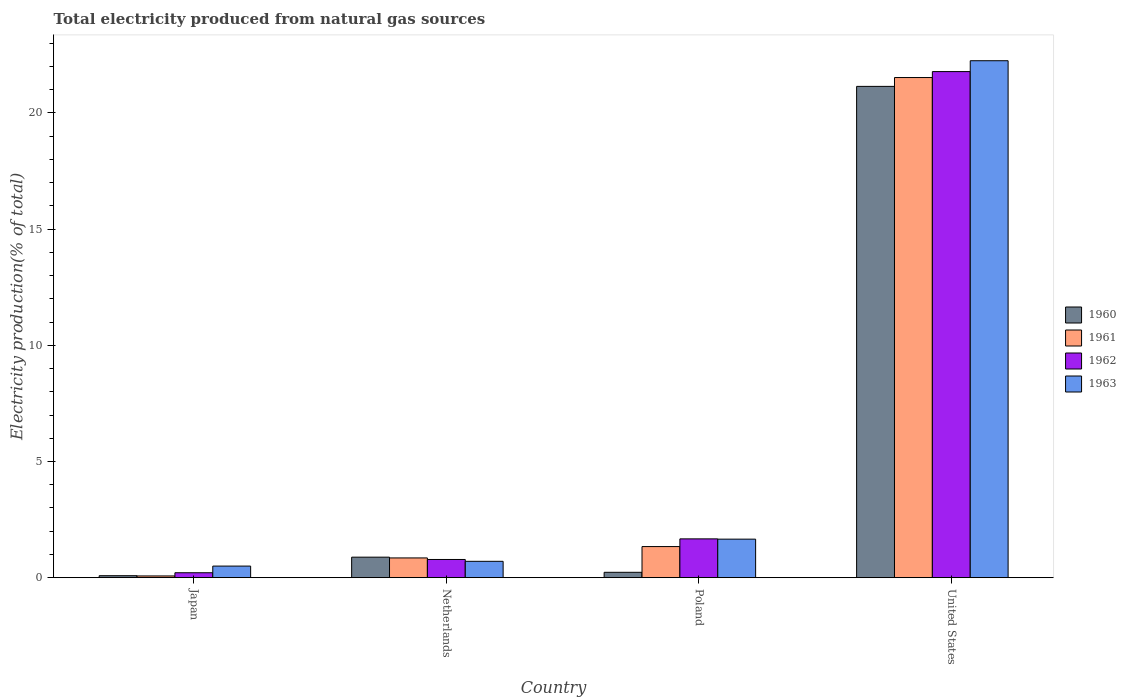How many different coloured bars are there?
Provide a short and direct response. 4. Are the number of bars per tick equal to the number of legend labels?
Offer a terse response. Yes. Are the number of bars on each tick of the X-axis equal?
Make the answer very short. Yes. How many bars are there on the 4th tick from the right?
Your answer should be compact. 4. In how many cases, is the number of bars for a given country not equal to the number of legend labels?
Your answer should be very brief. 0. What is the total electricity produced in 1963 in United States?
Ensure brevity in your answer.  22.24. Across all countries, what is the maximum total electricity produced in 1961?
Your answer should be very brief. 21.52. Across all countries, what is the minimum total electricity produced in 1962?
Your answer should be compact. 0.21. In which country was the total electricity produced in 1962 minimum?
Make the answer very short. Japan. What is the total total electricity produced in 1960 in the graph?
Offer a very short reply. 22.34. What is the difference between the total electricity produced in 1961 in Netherlands and that in United States?
Your answer should be compact. -20.67. What is the difference between the total electricity produced in 1963 in United States and the total electricity produced in 1960 in Netherlands?
Make the answer very short. 21.36. What is the average total electricity produced in 1961 per country?
Your answer should be compact. 5.95. What is the difference between the total electricity produced of/in 1962 and total electricity produced of/in 1961 in Netherlands?
Give a very brief answer. -0.07. What is the ratio of the total electricity produced in 1961 in Poland to that in United States?
Offer a very short reply. 0.06. Is the total electricity produced in 1962 in Japan less than that in Poland?
Offer a terse response. Yes. Is the difference between the total electricity produced in 1962 in Japan and United States greater than the difference between the total electricity produced in 1961 in Japan and United States?
Provide a succinct answer. No. What is the difference between the highest and the second highest total electricity produced in 1961?
Ensure brevity in your answer.  -0.49. What is the difference between the highest and the lowest total electricity produced in 1962?
Your response must be concise. 21.56. Is the sum of the total electricity produced in 1961 in Japan and Netherlands greater than the maximum total electricity produced in 1962 across all countries?
Your answer should be compact. No. Is it the case that in every country, the sum of the total electricity produced in 1960 and total electricity produced in 1961 is greater than the sum of total electricity produced in 1962 and total electricity produced in 1963?
Keep it short and to the point. No. Is it the case that in every country, the sum of the total electricity produced in 1963 and total electricity produced in 1960 is greater than the total electricity produced in 1961?
Ensure brevity in your answer.  Yes. How many countries are there in the graph?
Offer a very short reply. 4. Are the values on the major ticks of Y-axis written in scientific E-notation?
Your answer should be compact. No. Does the graph contain grids?
Ensure brevity in your answer.  No. What is the title of the graph?
Provide a succinct answer. Total electricity produced from natural gas sources. What is the label or title of the X-axis?
Offer a terse response. Country. What is the label or title of the Y-axis?
Give a very brief answer. Electricity production(% of total). What is the Electricity production(% of total) of 1960 in Japan?
Give a very brief answer. 0.09. What is the Electricity production(% of total) in 1961 in Japan?
Your answer should be very brief. 0.08. What is the Electricity production(% of total) of 1962 in Japan?
Your answer should be very brief. 0.21. What is the Electricity production(% of total) in 1963 in Japan?
Offer a terse response. 0.5. What is the Electricity production(% of total) of 1960 in Netherlands?
Give a very brief answer. 0.88. What is the Electricity production(% of total) in 1961 in Netherlands?
Your answer should be very brief. 0.85. What is the Electricity production(% of total) in 1962 in Netherlands?
Provide a short and direct response. 0.78. What is the Electricity production(% of total) of 1963 in Netherlands?
Make the answer very short. 0.71. What is the Electricity production(% of total) of 1960 in Poland?
Ensure brevity in your answer.  0.23. What is the Electricity production(% of total) in 1961 in Poland?
Your answer should be very brief. 1.34. What is the Electricity production(% of total) of 1962 in Poland?
Offer a terse response. 1.67. What is the Electricity production(% of total) in 1963 in Poland?
Your answer should be compact. 1.66. What is the Electricity production(% of total) of 1960 in United States?
Keep it short and to the point. 21.14. What is the Electricity production(% of total) of 1961 in United States?
Offer a terse response. 21.52. What is the Electricity production(% of total) of 1962 in United States?
Give a very brief answer. 21.78. What is the Electricity production(% of total) in 1963 in United States?
Provide a succinct answer. 22.24. Across all countries, what is the maximum Electricity production(% of total) of 1960?
Provide a short and direct response. 21.14. Across all countries, what is the maximum Electricity production(% of total) in 1961?
Keep it short and to the point. 21.52. Across all countries, what is the maximum Electricity production(% of total) of 1962?
Provide a succinct answer. 21.78. Across all countries, what is the maximum Electricity production(% of total) of 1963?
Your answer should be very brief. 22.24. Across all countries, what is the minimum Electricity production(% of total) in 1960?
Keep it short and to the point. 0.09. Across all countries, what is the minimum Electricity production(% of total) in 1961?
Your answer should be very brief. 0.08. Across all countries, what is the minimum Electricity production(% of total) of 1962?
Offer a very short reply. 0.21. Across all countries, what is the minimum Electricity production(% of total) in 1963?
Keep it short and to the point. 0.5. What is the total Electricity production(% of total) in 1960 in the graph?
Give a very brief answer. 22.34. What is the total Electricity production(% of total) of 1961 in the graph?
Your answer should be compact. 23.79. What is the total Electricity production(% of total) of 1962 in the graph?
Provide a succinct answer. 24.45. What is the total Electricity production(% of total) in 1963 in the graph?
Your answer should be compact. 25.11. What is the difference between the Electricity production(% of total) of 1960 in Japan and that in Netherlands?
Your answer should be very brief. -0.8. What is the difference between the Electricity production(% of total) of 1961 in Japan and that in Netherlands?
Offer a terse response. -0.78. What is the difference between the Electricity production(% of total) of 1962 in Japan and that in Netherlands?
Your answer should be compact. -0.57. What is the difference between the Electricity production(% of total) of 1963 in Japan and that in Netherlands?
Keep it short and to the point. -0.21. What is the difference between the Electricity production(% of total) of 1960 in Japan and that in Poland?
Give a very brief answer. -0.15. What is the difference between the Electricity production(% of total) in 1961 in Japan and that in Poland?
Offer a terse response. -1.26. What is the difference between the Electricity production(% of total) of 1962 in Japan and that in Poland?
Keep it short and to the point. -1.46. What is the difference between the Electricity production(% of total) in 1963 in Japan and that in Poland?
Provide a short and direct response. -1.16. What is the difference between the Electricity production(% of total) of 1960 in Japan and that in United States?
Your answer should be compact. -21.05. What is the difference between the Electricity production(% of total) of 1961 in Japan and that in United States?
Offer a very short reply. -21.45. What is the difference between the Electricity production(% of total) in 1962 in Japan and that in United States?
Keep it short and to the point. -21.56. What is the difference between the Electricity production(% of total) in 1963 in Japan and that in United States?
Provide a short and direct response. -21.74. What is the difference between the Electricity production(% of total) in 1960 in Netherlands and that in Poland?
Offer a very short reply. 0.65. What is the difference between the Electricity production(% of total) in 1961 in Netherlands and that in Poland?
Your answer should be compact. -0.49. What is the difference between the Electricity production(% of total) in 1962 in Netherlands and that in Poland?
Ensure brevity in your answer.  -0.89. What is the difference between the Electricity production(% of total) of 1963 in Netherlands and that in Poland?
Keep it short and to the point. -0.95. What is the difference between the Electricity production(% of total) in 1960 in Netherlands and that in United States?
Your answer should be compact. -20.26. What is the difference between the Electricity production(% of total) in 1961 in Netherlands and that in United States?
Provide a short and direct response. -20.67. What is the difference between the Electricity production(% of total) of 1962 in Netherlands and that in United States?
Your answer should be compact. -20.99. What is the difference between the Electricity production(% of total) of 1963 in Netherlands and that in United States?
Your answer should be compact. -21.54. What is the difference between the Electricity production(% of total) of 1960 in Poland and that in United States?
Offer a very short reply. -20.91. What is the difference between the Electricity production(% of total) of 1961 in Poland and that in United States?
Your answer should be very brief. -20.18. What is the difference between the Electricity production(% of total) in 1962 in Poland and that in United States?
Ensure brevity in your answer.  -20.11. What is the difference between the Electricity production(% of total) of 1963 in Poland and that in United States?
Give a very brief answer. -20.59. What is the difference between the Electricity production(% of total) in 1960 in Japan and the Electricity production(% of total) in 1961 in Netherlands?
Offer a terse response. -0.76. What is the difference between the Electricity production(% of total) of 1960 in Japan and the Electricity production(% of total) of 1962 in Netherlands?
Your response must be concise. -0.7. What is the difference between the Electricity production(% of total) of 1960 in Japan and the Electricity production(% of total) of 1963 in Netherlands?
Ensure brevity in your answer.  -0.62. What is the difference between the Electricity production(% of total) of 1961 in Japan and the Electricity production(% of total) of 1962 in Netherlands?
Provide a succinct answer. -0.71. What is the difference between the Electricity production(% of total) in 1961 in Japan and the Electricity production(% of total) in 1963 in Netherlands?
Your answer should be compact. -0.63. What is the difference between the Electricity production(% of total) in 1962 in Japan and the Electricity production(% of total) in 1963 in Netherlands?
Ensure brevity in your answer.  -0.49. What is the difference between the Electricity production(% of total) in 1960 in Japan and the Electricity production(% of total) in 1961 in Poland?
Provide a short and direct response. -1.25. What is the difference between the Electricity production(% of total) in 1960 in Japan and the Electricity production(% of total) in 1962 in Poland?
Offer a very short reply. -1.58. What is the difference between the Electricity production(% of total) of 1960 in Japan and the Electricity production(% of total) of 1963 in Poland?
Give a very brief answer. -1.57. What is the difference between the Electricity production(% of total) of 1961 in Japan and the Electricity production(% of total) of 1962 in Poland?
Keep it short and to the point. -1.6. What is the difference between the Electricity production(% of total) in 1961 in Japan and the Electricity production(% of total) in 1963 in Poland?
Keep it short and to the point. -1.58. What is the difference between the Electricity production(% of total) in 1962 in Japan and the Electricity production(% of total) in 1963 in Poland?
Offer a terse response. -1.45. What is the difference between the Electricity production(% of total) of 1960 in Japan and the Electricity production(% of total) of 1961 in United States?
Provide a succinct answer. -21.43. What is the difference between the Electricity production(% of total) of 1960 in Japan and the Electricity production(% of total) of 1962 in United States?
Give a very brief answer. -21.69. What is the difference between the Electricity production(% of total) of 1960 in Japan and the Electricity production(% of total) of 1963 in United States?
Make the answer very short. -22.16. What is the difference between the Electricity production(% of total) of 1961 in Japan and the Electricity production(% of total) of 1962 in United States?
Your answer should be compact. -21.7. What is the difference between the Electricity production(% of total) of 1961 in Japan and the Electricity production(% of total) of 1963 in United States?
Offer a terse response. -22.17. What is the difference between the Electricity production(% of total) of 1962 in Japan and the Electricity production(% of total) of 1963 in United States?
Your answer should be compact. -22.03. What is the difference between the Electricity production(% of total) of 1960 in Netherlands and the Electricity production(% of total) of 1961 in Poland?
Offer a terse response. -0.46. What is the difference between the Electricity production(% of total) of 1960 in Netherlands and the Electricity production(% of total) of 1962 in Poland?
Your response must be concise. -0.79. What is the difference between the Electricity production(% of total) in 1960 in Netherlands and the Electricity production(% of total) in 1963 in Poland?
Ensure brevity in your answer.  -0.78. What is the difference between the Electricity production(% of total) in 1961 in Netherlands and the Electricity production(% of total) in 1962 in Poland?
Make the answer very short. -0.82. What is the difference between the Electricity production(% of total) of 1961 in Netherlands and the Electricity production(% of total) of 1963 in Poland?
Your answer should be very brief. -0.81. What is the difference between the Electricity production(% of total) of 1962 in Netherlands and the Electricity production(% of total) of 1963 in Poland?
Provide a succinct answer. -0.88. What is the difference between the Electricity production(% of total) of 1960 in Netherlands and the Electricity production(% of total) of 1961 in United States?
Offer a terse response. -20.64. What is the difference between the Electricity production(% of total) in 1960 in Netherlands and the Electricity production(% of total) in 1962 in United States?
Provide a succinct answer. -20.89. What is the difference between the Electricity production(% of total) in 1960 in Netherlands and the Electricity production(% of total) in 1963 in United States?
Your answer should be compact. -21.36. What is the difference between the Electricity production(% of total) in 1961 in Netherlands and the Electricity production(% of total) in 1962 in United States?
Provide a short and direct response. -20.93. What is the difference between the Electricity production(% of total) in 1961 in Netherlands and the Electricity production(% of total) in 1963 in United States?
Offer a very short reply. -21.39. What is the difference between the Electricity production(% of total) in 1962 in Netherlands and the Electricity production(% of total) in 1963 in United States?
Your answer should be compact. -21.46. What is the difference between the Electricity production(% of total) in 1960 in Poland and the Electricity production(% of total) in 1961 in United States?
Provide a short and direct response. -21.29. What is the difference between the Electricity production(% of total) in 1960 in Poland and the Electricity production(% of total) in 1962 in United States?
Keep it short and to the point. -21.55. What is the difference between the Electricity production(% of total) of 1960 in Poland and the Electricity production(% of total) of 1963 in United States?
Keep it short and to the point. -22.01. What is the difference between the Electricity production(% of total) of 1961 in Poland and the Electricity production(% of total) of 1962 in United States?
Your response must be concise. -20.44. What is the difference between the Electricity production(% of total) of 1961 in Poland and the Electricity production(% of total) of 1963 in United States?
Your answer should be compact. -20.91. What is the difference between the Electricity production(% of total) of 1962 in Poland and the Electricity production(% of total) of 1963 in United States?
Offer a terse response. -20.57. What is the average Electricity production(% of total) in 1960 per country?
Your answer should be very brief. 5.59. What is the average Electricity production(% of total) of 1961 per country?
Provide a succinct answer. 5.95. What is the average Electricity production(% of total) of 1962 per country?
Your answer should be compact. 6.11. What is the average Electricity production(% of total) of 1963 per country?
Provide a short and direct response. 6.28. What is the difference between the Electricity production(% of total) in 1960 and Electricity production(% of total) in 1961 in Japan?
Provide a succinct answer. 0.01. What is the difference between the Electricity production(% of total) of 1960 and Electricity production(% of total) of 1962 in Japan?
Provide a short and direct response. -0.13. What is the difference between the Electricity production(% of total) of 1960 and Electricity production(% of total) of 1963 in Japan?
Your answer should be compact. -0.41. What is the difference between the Electricity production(% of total) of 1961 and Electricity production(% of total) of 1962 in Japan?
Provide a short and direct response. -0.14. What is the difference between the Electricity production(% of total) of 1961 and Electricity production(% of total) of 1963 in Japan?
Offer a terse response. -0.42. What is the difference between the Electricity production(% of total) of 1962 and Electricity production(% of total) of 1963 in Japan?
Your response must be concise. -0.29. What is the difference between the Electricity production(% of total) of 1960 and Electricity production(% of total) of 1961 in Netherlands?
Your answer should be compact. 0.03. What is the difference between the Electricity production(% of total) in 1960 and Electricity production(% of total) in 1962 in Netherlands?
Ensure brevity in your answer.  0.1. What is the difference between the Electricity production(% of total) in 1960 and Electricity production(% of total) in 1963 in Netherlands?
Give a very brief answer. 0.18. What is the difference between the Electricity production(% of total) in 1961 and Electricity production(% of total) in 1962 in Netherlands?
Your answer should be compact. 0.07. What is the difference between the Electricity production(% of total) of 1961 and Electricity production(% of total) of 1963 in Netherlands?
Ensure brevity in your answer.  0.15. What is the difference between the Electricity production(% of total) in 1962 and Electricity production(% of total) in 1963 in Netherlands?
Offer a terse response. 0.08. What is the difference between the Electricity production(% of total) in 1960 and Electricity production(% of total) in 1961 in Poland?
Offer a terse response. -1.11. What is the difference between the Electricity production(% of total) of 1960 and Electricity production(% of total) of 1962 in Poland?
Offer a very short reply. -1.44. What is the difference between the Electricity production(% of total) of 1960 and Electricity production(% of total) of 1963 in Poland?
Give a very brief answer. -1.43. What is the difference between the Electricity production(% of total) of 1961 and Electricity production(% of total) of 1962 in Poland?
Offer a very short reply. -0.33. What is the difference between the Electricity production(% of total) of 1961 and Electricity production(% of total) of 1963 in Poland?
Keep it short and to the point. -0.32. What is the difference between the Electricity production(% of total) of 1962 and Electricity production(% of total) of 1963 in Poland?
Your answer should be compact. 0.01. What is the difference between the Electricity production(% of total) of 1960 and Electricity production(% of total) of 1961 in United States?
Offer a very short reply. -0.38. What is the difference between the Electricity production(% of total) of 1960 and Electricity production(% of total) of 1962 in United States?
Keep it short and to the point. -0.64. What is the difference between the Electricity production(% of total) of 1960 and Electricity production(% of total) of 1963 in United States?
Keep it short and to the point. -1.1. What is the difference between the Electricity production(% of total) in 1961 and Electricity production(% of total) in 1962 in United States?
Make the answer very short. -0.26. What is the difference between the Electricity production(% of total) in 1961 and Electricity production(% of total) in 1963 in United States?
Provide a short and direct response. -0.72. What is the difference between the Electricity production(% of total) in 1962 and Electricity production(% of total) in 1963 in United States?
Offer a terse response. -0.47. What is the ratio of the Electricity production(% of total) of 1960 in Japan to that in Netherlands?
Offer a terse response. 0.1. What is the ratio of the Electricity production(% of total) in 1961 in Japan to that in Netherlands?
Your response must be concise. 0.09. What is the ratio of the Electricity production(% of total) of 1962 in Japan to that in Netherlands?
Provide a short and direct response. 0.27. What is the ratio of the Electricity production(% of total) in 1963 in Japan to that in Netherlands?
Offer a very short reply. 0.71. What is the ratio of the Electricity production(% of total) in 1960 in Japan to that in Poland?
Your answer should be very brief. 0.37. What is the ratio of the Electricity production(% of total) of 1961 in Japan to that in Poland?
Provide a short and direct response. 0.06. What is the ratio of the Electricity production(% of total) of 1962 in Japan to that in Poland?
Your answer should be compact. 0.13. What is the ratio of the Electricity production(% of total) of 1963 in Japan to that in Poland?
Your answer should be compact. 0.3. What is the ratio of the Electricity production(% of total) of 1960 in Japan to that in United States?
Provide a succinct answer. 0. What is the ratio of the Electricity production(% of total) of 1961 in Japan to that in United States?
Your response must be concise. 0. What is the ratio of the Electricity production(% of total) of 1962 in Japan to that in United States?
Ensure brevity in your answer.  0.01. What is the ratio of the Electricity production(% of total) in 1963 in Japan to that in United States?
Your answer should be compact. 0.02. What is the ratio of the Electricity production(% of total) in 1960 in Netherlands to that in Poland?
Offer a terse response. 3.81. What is the ratio of the Electricity production(% of total) of 1961 in Netherlands to that in Poland?
Your answer should be very brief. 0.64. What is the ratio of the Electricity production(% of total) in 1962 in Netherlands to that in Poland?
Provide a succinct answer. 0.47. What is the ratio of the Electricity production(% of total) in 1963 in Netherlands to that in Poland?
Keep it short and to the point. 0.42. What is the ratio of the Electricity production(% of total) of 1960 in Netherlands to that in United States?
Offer a terse response. 0.04. What is the ratio of the Electricity production(% of total) in 1961 in Netherlands to that in United States?
Provide a short and direct response. 0.04. What is the ratio of the Electricity production(% of total) in 1962 in Netherlands to that in United States?
Offer a terse response. 0.04. What is the ratio of the Electricity production(% of total) in 1963 in Netherlands to that in United States?
Offer a very short reply. 0.03. What is the ratio of the Electricity production(% of total) of 1960 in Poland to that in United States?
Make the answer very short. 0.01. What is the ratio of the Electricity production(% of total) of 1961 in Poland to that in United States?
Your answer should be compact. 0.06. What is the ratio of the Electricity production(% of total) in 1962 in Poland to that in United States?
Your answer should be compact. 0.08. What is the ratio of the Electricity production(% of total) of 1963 in Poland to that in United States?
Make the answer very short. 0.07. What is the difference between the highest and the second highest Electricity production(% of total) in 1960?
Make the answer very short. 20.26. What is the difference between the highest and the second highest Electricity production(% of total) of 1961?
Ensure brevity in your answer.  20.18. What is the difference between the highest and the second highest Electricity production(% of total) of 1962?
Offer a terse response. 20.11. What is the difference between the highest and the second highest Electricity production(% of total) in 1963?
Provide a short and direct response. 20.59. What is the difference between the highest and the lowest Electricity production(% of total) in 1960?
Ensure brevity in your answer.  21.05. What is the difference between the highest and the lowest Electricity production(% of total) of 1961?
Provide a short and direct response. 21.45. What is the difference between the highest and the lowest Electricity production(% of total) of 1962?
Offer a very short reply. 21.56. What is the difference between the highest and the lowest Electricity production(% of total) of 1963?
Offer a very short reply. 21.74. 